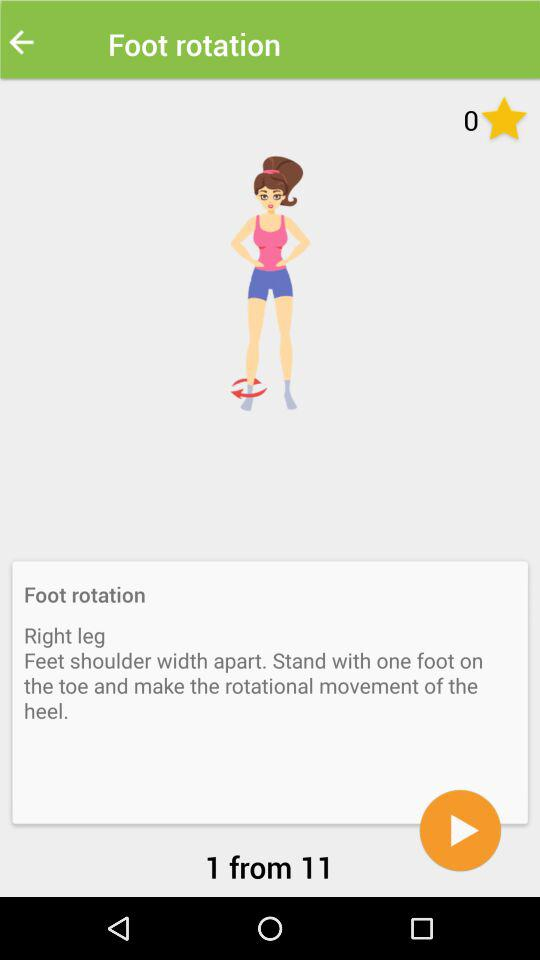How many steps are left in this exercise?
Answer the question using a single word or phrase. 10 